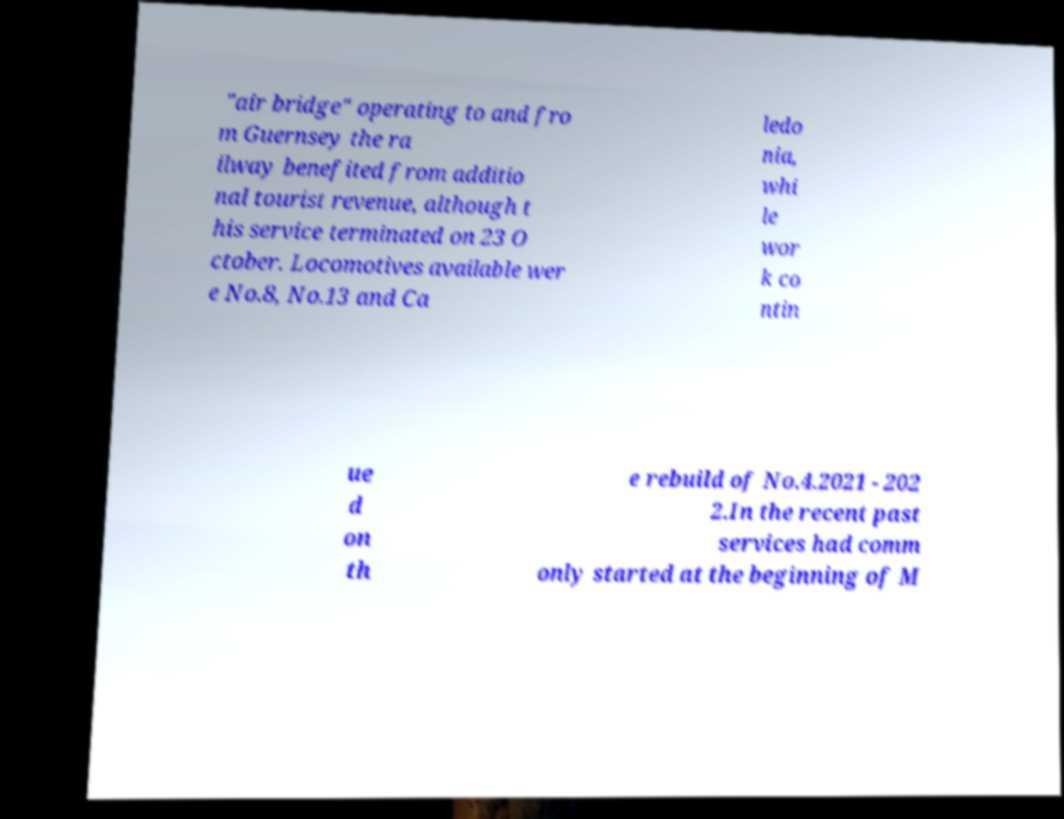What messages or text are displayed in this image? I need them in a readable, typed format. "air bridge" operating to and fro m Guernsey the ra ilway benefited from additio nal tourist revenue, although t his service terminated on 23 O ctober. Locomotives available wer e No.8, No.13 and Ca ledo nia, whi le wor k co ntin ue d on th e rebuild of No.4.2021 - 202 2.In the recent past services had comm only started at the beginning of M 